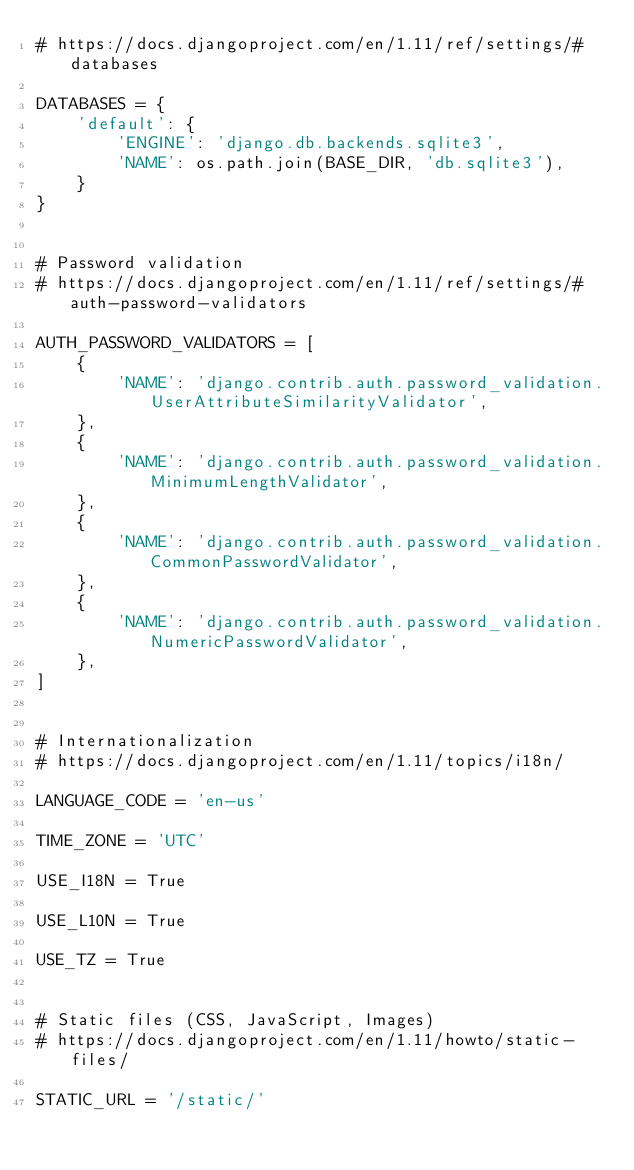<code> <loc_0><loc_0><loc_500><loc_500><_Python_># https://docs.djangoproject.com/en/1.11/ref/settings/#databases

DATABASES = {
    'default': {
        'ENGINE': 'django.db.backends.sqlite3',
        'NAME': os.path.join(BASE_DIR, 'db.sqlite3'),
    }
}


# Password validation
# https://docs.djangoproject.com/en/1.11/ref/settings/#auth-password-validators

AUTH_PASSWORD_VALIDATORS = [
    {
        'NAME': 'django.contrib.auth.password_validation.UserAttributeSimilarityValidator',
    },
    {
        'NAME': 'django.contrib.auth.password_validation.MinimumLengthValidator',
    },
    {
        'NAME': 'django.contrib.auth.password_validation.CommonPasswordValidator',
    },
    {
        'NAME': 'django.contrib.auth.password_validation.NumericPasswordValidator',
    },
]


# Internationalization
# https://docs.djangoproject.com/en/1.11/topics/i18n/

LANGUAGE_CODE = 'en-us'

TIME_ZONE = 'UTC'

USE_I18N = True

USE_L10N = True

USE_TZ = True


# Static files (CSS, JavaScript, Images)
# https://docs.djangoproject.com/en/1.11/howto/static-files/

STATIC_URL = '/static/'
</code> 